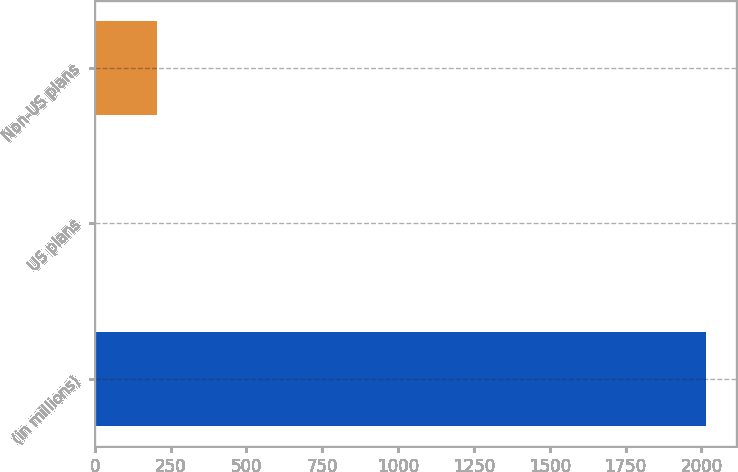Convert chart to OTSL. <chart><loc_0><loc_0><loc_500><loc_500><bar_chart><fcel>(in millions)<fcel>US plans<fcel>Non-US plans<nl><fcel>2014<fcel>5<fcel>205.9<nl></chart> 